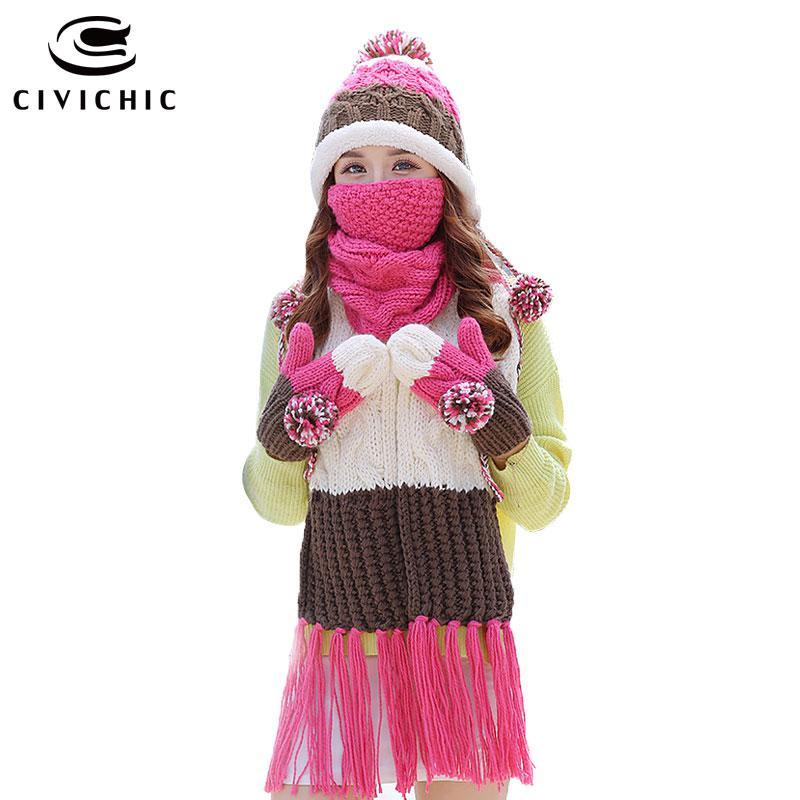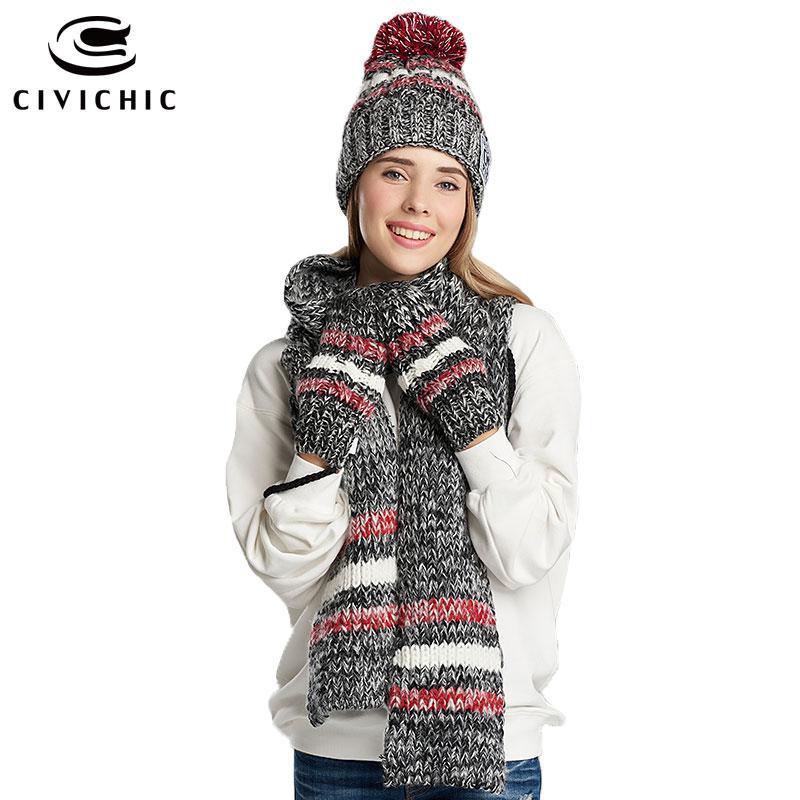The first image is the image on the left, the second image is the image on the right. Analyze the images presented: Is the assertion "there is a girl with a scarf covering the bottom half of her face" valid? Answer yes or no. Yes. The first image is the image on the left, the second image is the image on the right. Examine the images to the left and right. Is the description "A young girl is wearing a matching scarf, hat and gloves set that is white, brown and pink." accurate? Answer yes or no. Yes. 